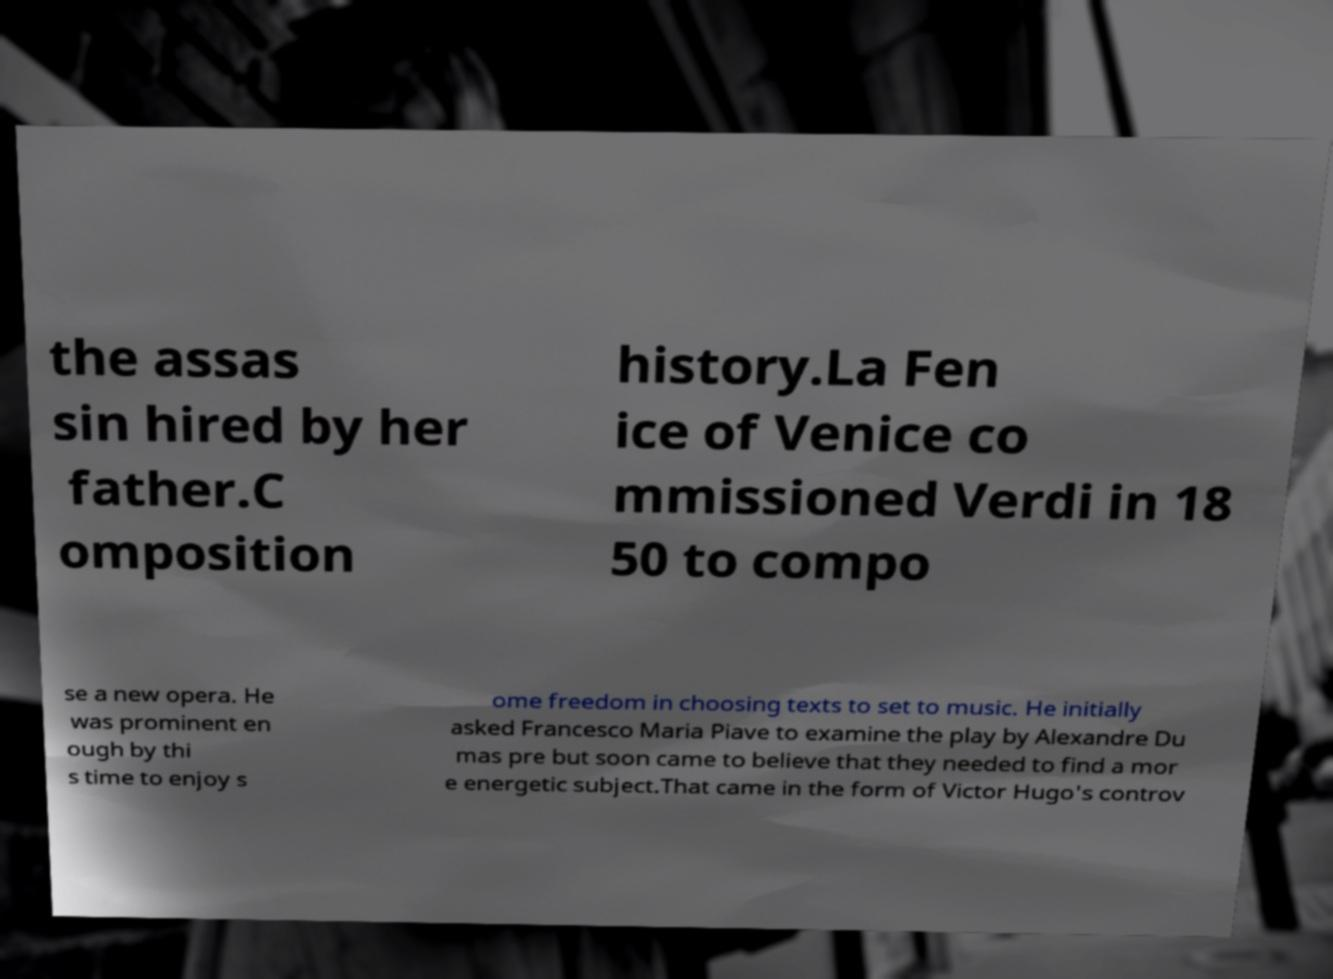Please identify and transcribe the text found in this image. the assas sin hired by her father.C omposition history.La Fen ice of Venice co mmissioned Verdi in 18 50 to compo se a new opera. He was prominent en ough by thi s time to enjoy s ome freedom in choosing texts to set to music. He initially asked Francesco Maria Piave to examine the play by Alexandre Du mas pre but soon came to believe that they needed to find a mor e energetic subject.That came in the form of Victor Hugo's controv 